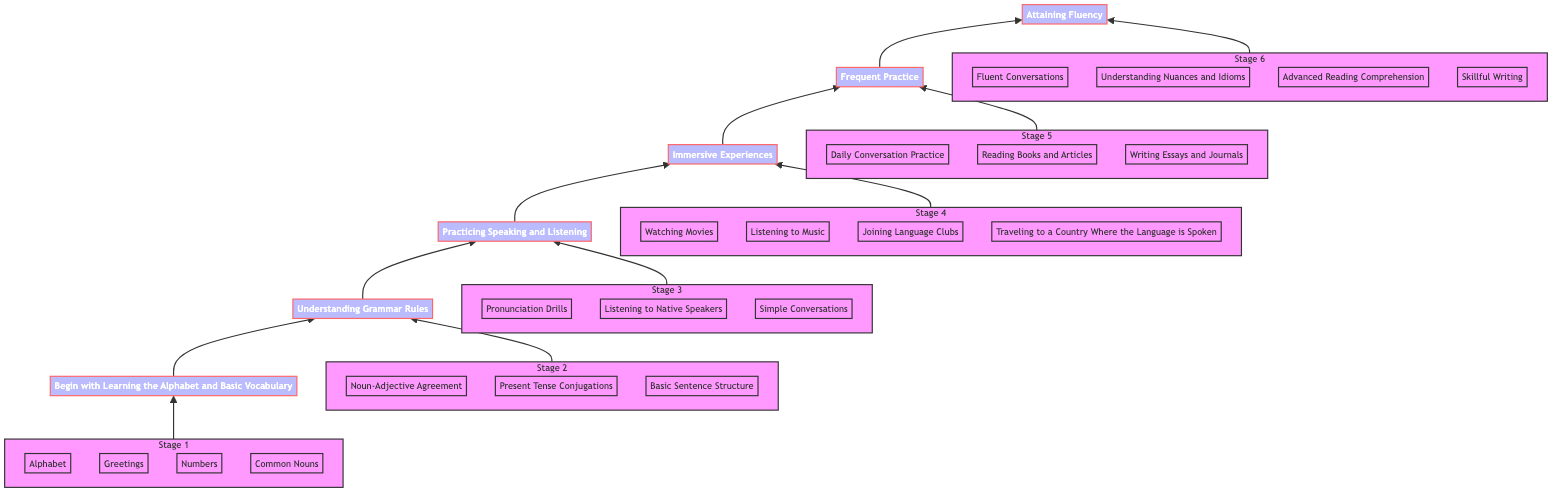What's the first stage in the fluency journey? The first stage in the diagram is "Begin with Learning the Alphabet and Basic Vocabulary." It is the bottom-most node and serves as the starting point.
Answer: Begin with Learning the Alphabet and Basic Vocabulary How many total stages are there in mastering a new language? The diagram shows a total of six stages, as indicated by the arrows leading from the bottom node to the top node.
Answer: Six What is the last stage in the diagram? The last stage at the top of the flow chart is "Attaining Fluency," which signifies the culmination of the learning process.
Answer: Attaining Fluency What is the specific focus of the third stage? The third stage is focused on "Practicing Speaking and Listening," which emphasizes the importance of verbal communication skills in language learning.
Answer: Practicing Speaking and Listening What type of experiences are highlighted in the fourth stage? The fourth stage emphasizes "Immersive Experiences," which involve engaging with the language in real-world settings, such as through movies and interactions.
Answer: Immersive Experiences Which stage must you complete before "Frequent Practice"? You must complete "Immersive Experiences" before moving on to "Frequent Practice," as indicated by the flow of arrows going upward through the diagram.
Answer: Immersive Experiences What are two examples of activities in the last stage? In the last stage, examples of activities include "Fluent Conversations" and "Understanding Nuances and Idioms," which illustrate the depth of fluency achieved.
Answer: Fluent Conversations and Understanding Nuances and Idioms Which stage introduces grammar concepts? The second stage, "Understanding Grammar Rules," introduces essential grammar concepts that serve as the foundation for constructing sentences in the new language.
Answer: Understanding Grammar Rules What is the primary activity suggested in the first stage? The primary activity suggested in the first stage is learning "basic words and phrases used in everyday conversations," crucial for initial language acquisition.
Answer: Basic words and phrases 